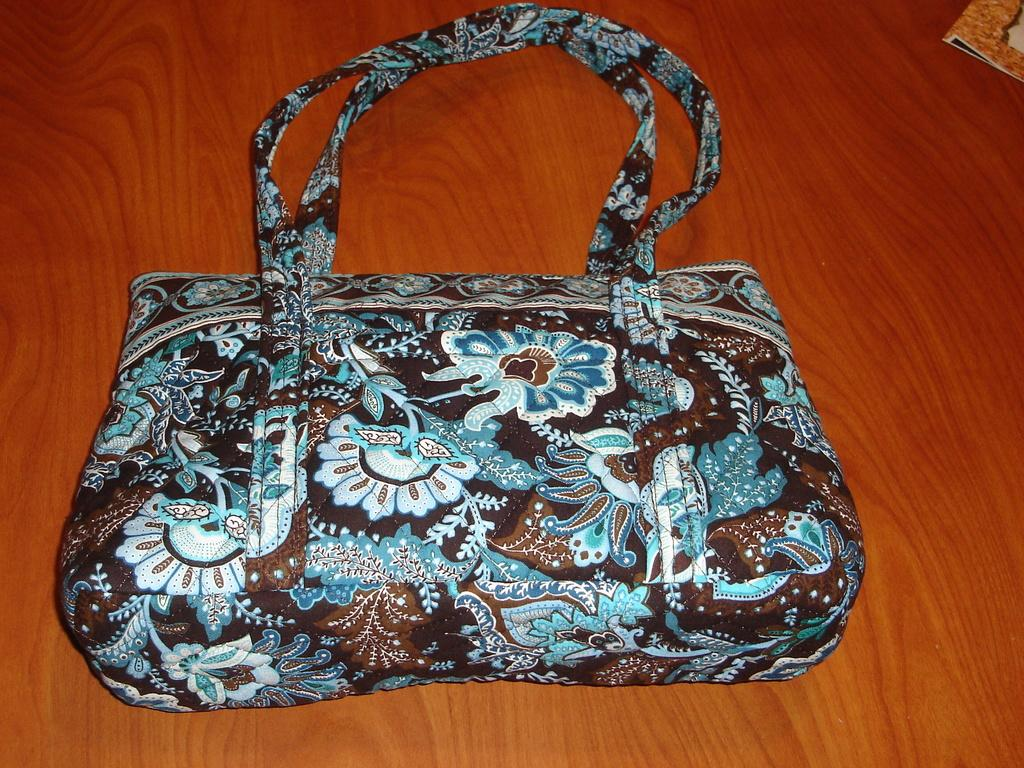What type of furniture is present in the image? There is a table in the image. Where is the bag located in relation to the table? The bag is placed on the corner of the table. What else can be seen in the image besides the table and bag? There is a book in the image. What type of polish is being applied to the trees in the image? There are no trees or polish present in the image. Can you describe the bee's behavior in the image? There are no bees present in the image. 